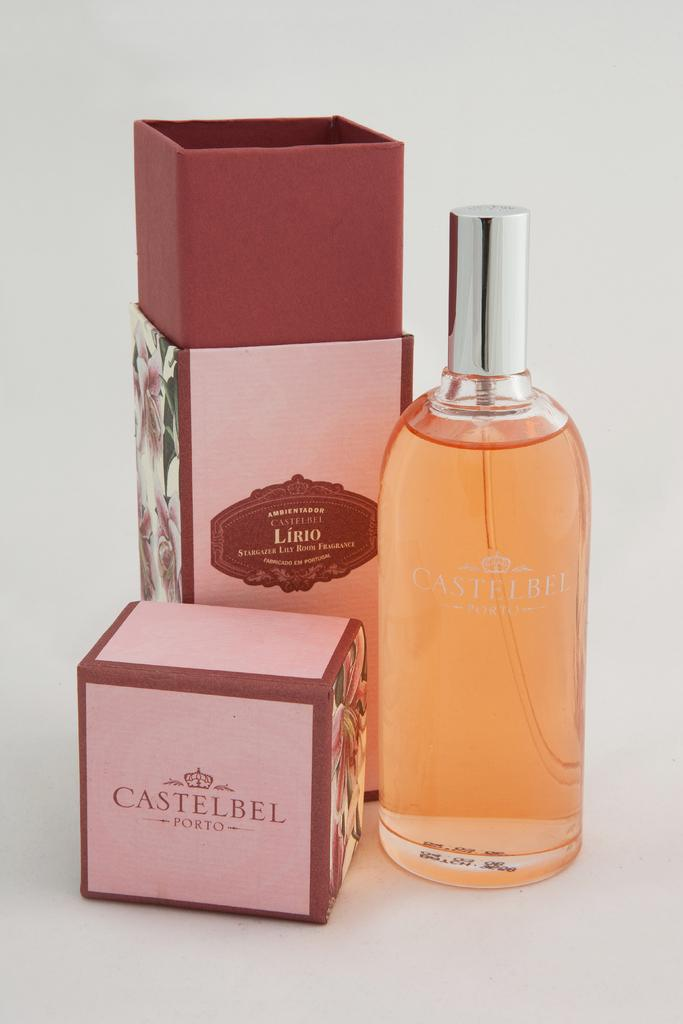<image>
Provide a brief description of the given image. A two tone pink gift box for Castelbel Porto next to a bottle of it. 